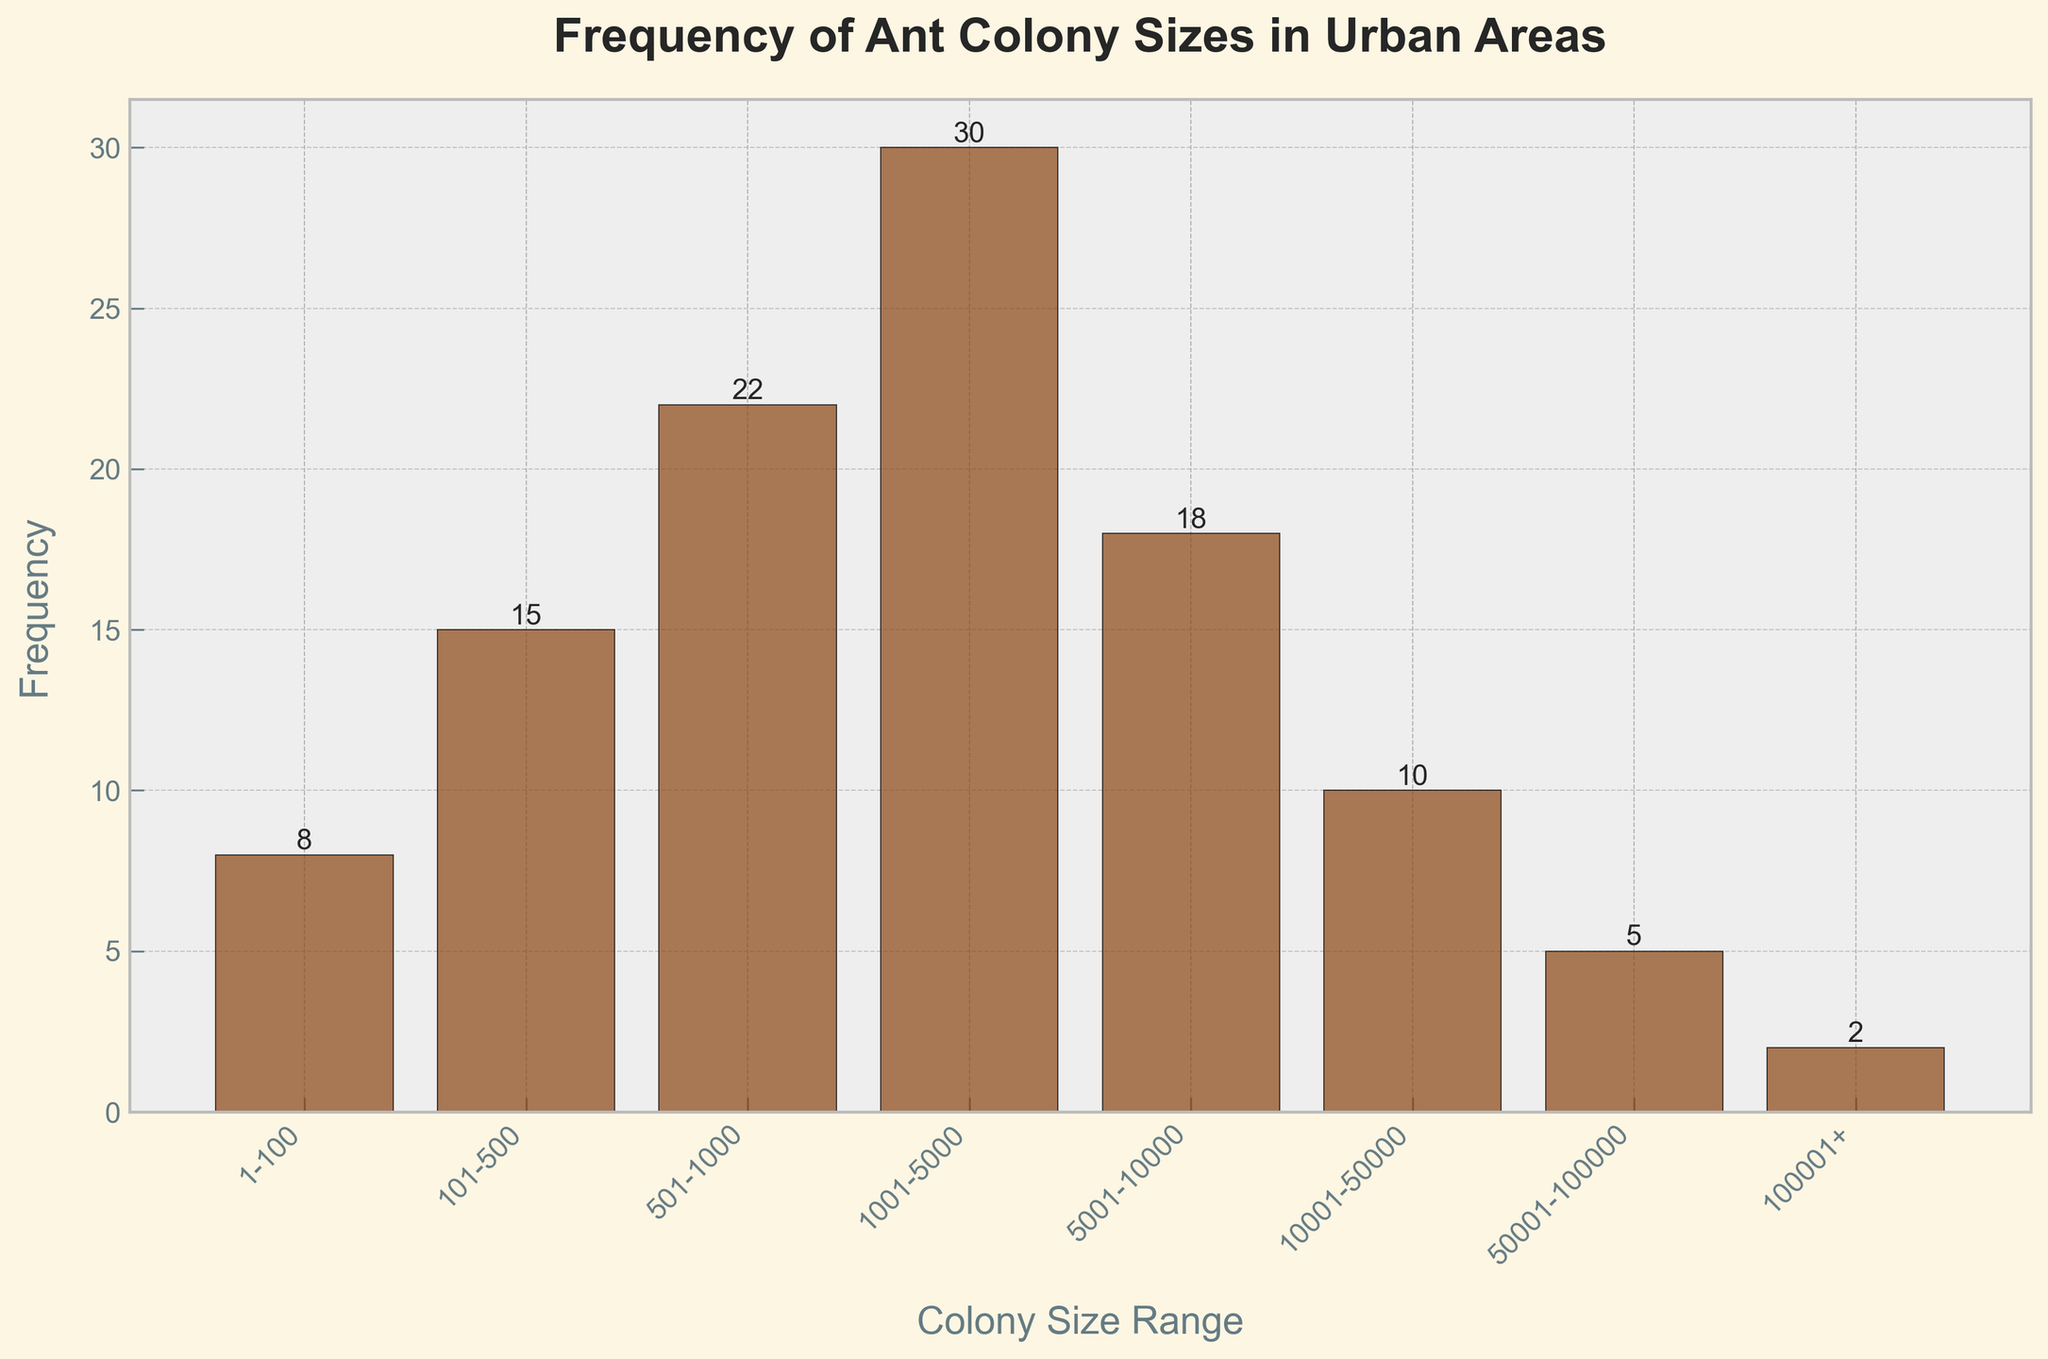What is the title of the histogram? The title of the histogram is at the top of the figure, usually in a larger and bolded font that describes the main topic of the chart.
Answer: Frequency of Ant Colony Sizes in Urban Areas What is the range with the highest frequency? Look at the height of the bars; the tallest one represents the highest frequency. Identify the Colony Size Range label on the x-axis corresponding to this bar.
Answer: 1001-5000 How many colony sizes have a frequency higher than 15? Count all the bars that have a height greater than 15 units on the y-axis.
Answer: Three What’s the total frequency of ant colonies in the range 1-1000? Sum the frequencies of the bars labeled 1-100, 101-500, and 501-1000. The frequencies are 8, 15, and 22 respectively.
Answer: 45 Which colony size range has the lowest frequency? Identify the shortest bar in terms of height and read the x-axis label corresponding to this bar.
Answer: 100001+ How many bars represent colony sizes with frequencies less than 10? Count bars where the heights are less than 10 units on the y-axis.
Answer: Three Compare the frequency of colonies in the 5001-10000 range to those in the 501-1000 range. Which one is higher? Compare the height of the bar labeled 5001-10000 to the one labeled 501-1000. The bar with greater height has a higher frequency.
Answer: 5001-10000 What is the difference in frequency between the largest and smallest colony size ranges? Subtract the frequency of the 100001+ range (smallest frequency) from the frequency of the 1001-5000 range (largest frequency). The frequencies are 2 and 30 respectively.
Answer: 28 If you sum up the frequencies of the two smallest colony size ranges, what do you get? Add the frequencies of the bars labeled 1-100 and 101-500. The frequencies are 8 and 15, respectively.
Answer: 23 